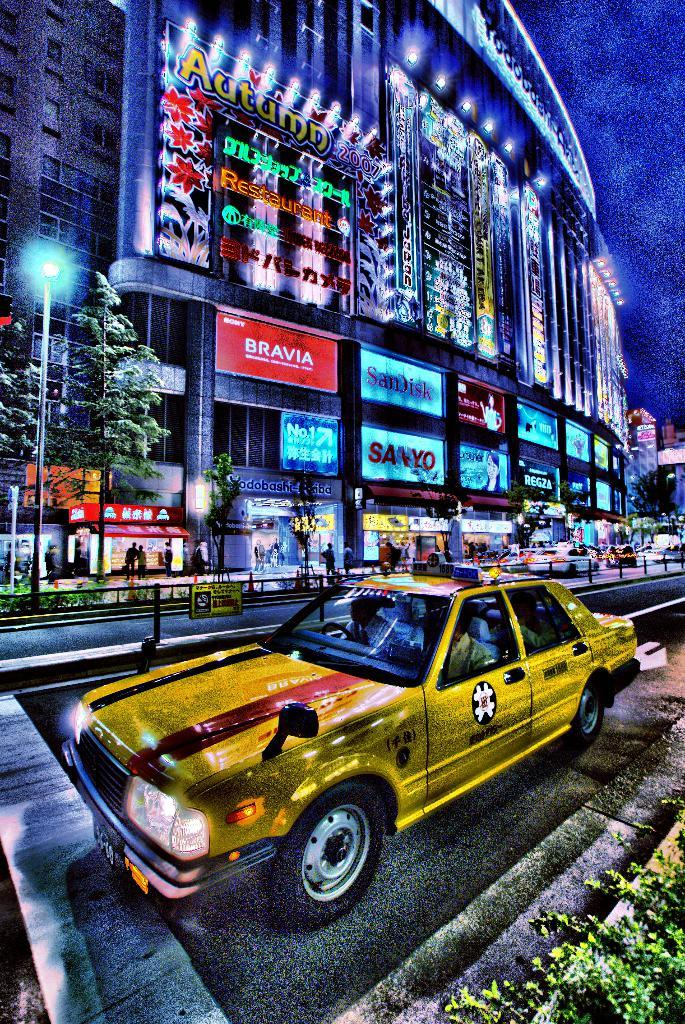<image>
Create a compact narrative representing the image presented. A cartoon drawing shows a yellow taxi cab on the road, just past an establishment with a red sign above the entrance that says Bravia. 